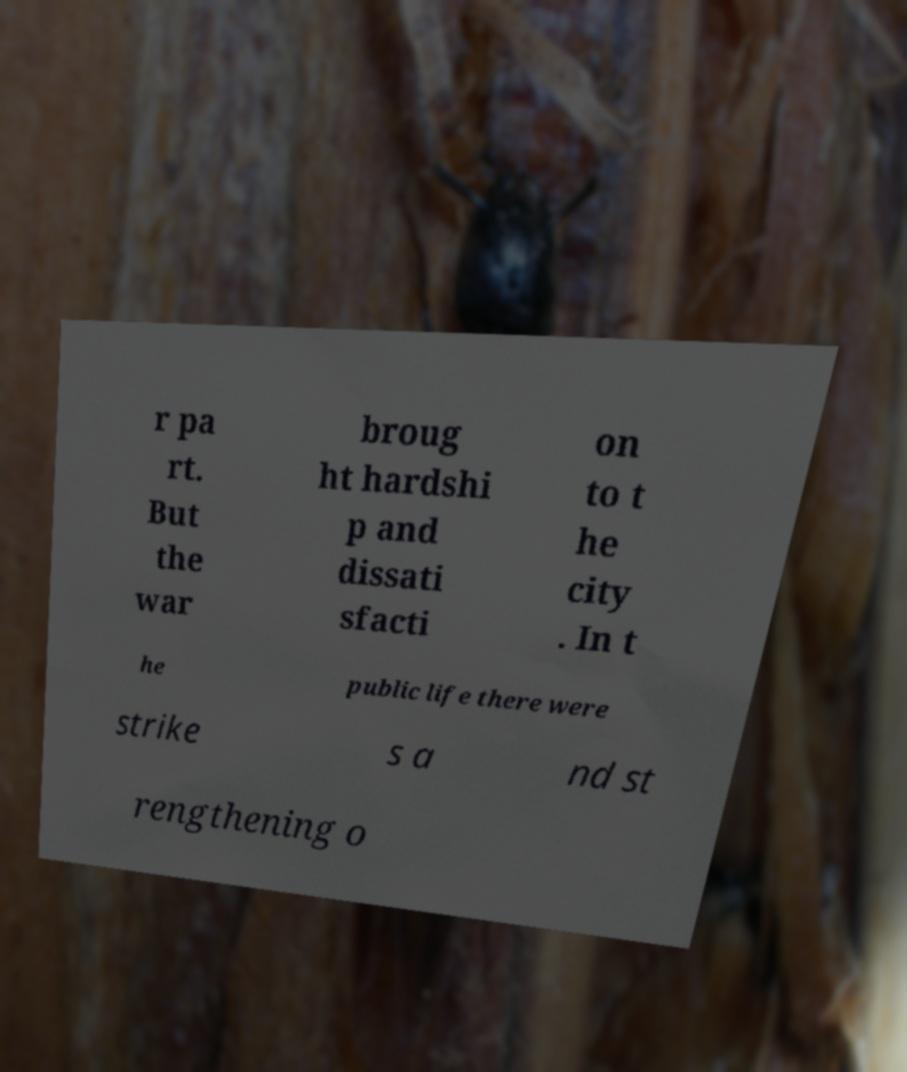Can you accurately transcribe the text from the provided image for me? r pa rt. But the war broug ht hardshi p and dissati sfacti on to t he city . In t he public life there were strike s a nd st rengthening o 